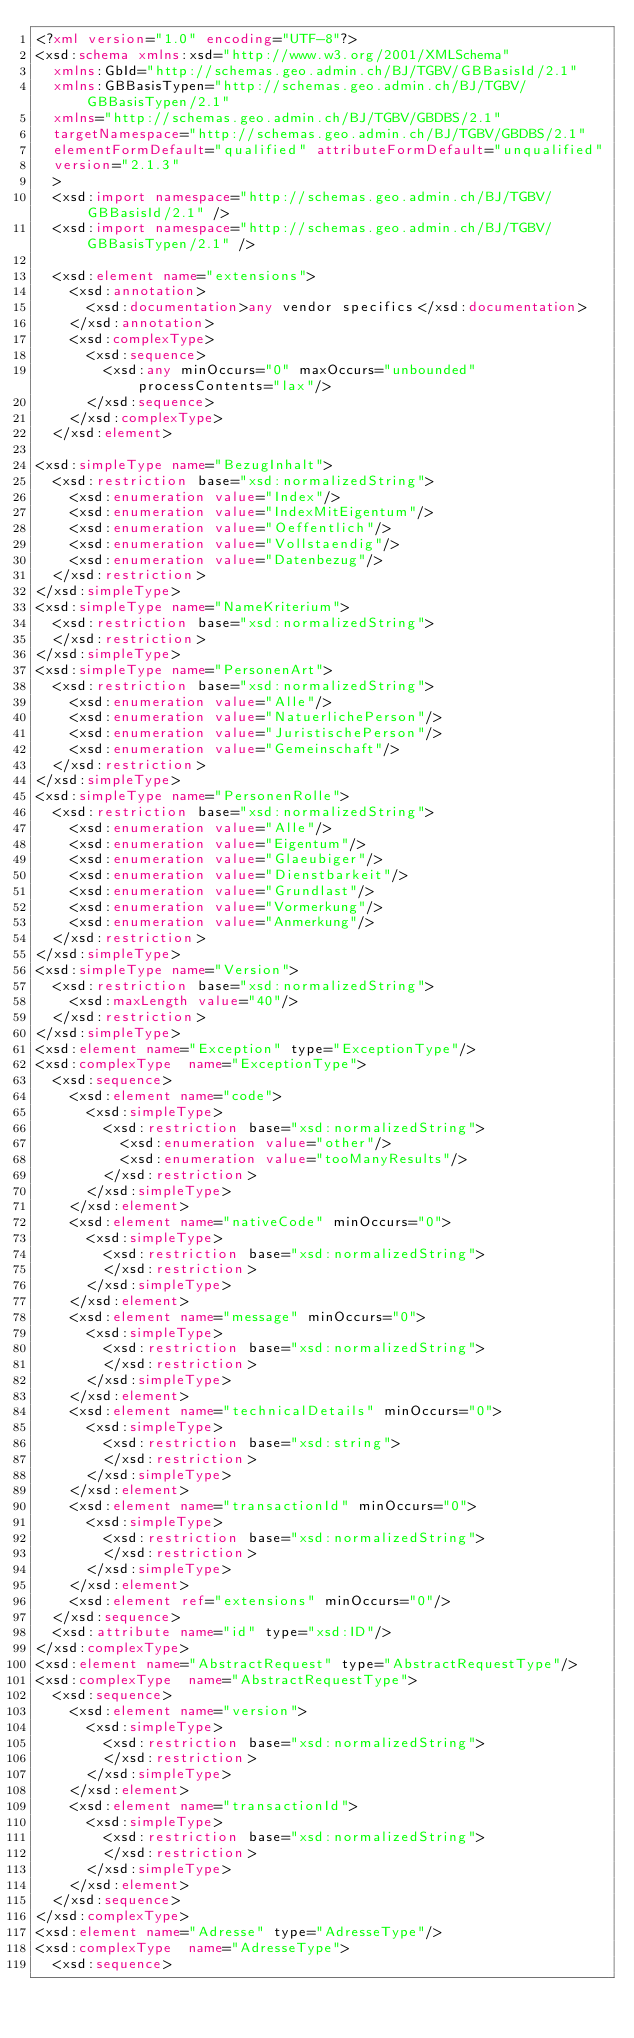<code> <loc_0><loc_0><loc_500><loc_500><_XML_><?xml version="1.0" encoding="UTF-8"?>
<xsd:schema xmlns:xsd="http://www.w3.org/2001/XMLSchema"
  xmlns:GbId="http://schemas.geo.admin.ch/BJ/TGBV/GBBasisId/2.1"
  xmlns:GBBasisTypen="http://schemas.geo.admin.ch/BJ/TGBV/GBBasisTypen/2.1"
  xmlns="http://schemas.geo.admin.ch/BJ/TGBV/GBDBS/2.1" 
  targetNamespace="http://schemas.geo.admin.ch/BJ/TGBV/GBDBS/2.1" 
  elementFormDefault="qualified" attributeFormDefault="unqualified"
  version="2.1.3"
  >
  <xsd:import namespace="http://schemas.geo.admin.ch/BJ/TGBV/GBBasisId/2.1" />
  <xsd:import namespace="http://schemas.geo.admin.ch/BJ/TGBV/GBBasisTypen/2.1" />

  <xsd:element name="extensions">
    <xsd:annotation>
      <xsd:documentation>any vendor specifics</xsd:documentation>
    </xsd:annotation>
    <xsd:complexType>
      <xsd:sequence>
        <xsd:any minOccurs="0" maxOccurs="unbounded" processContents="lax"/>
      </xsd:sequence>
    </xsd:complexType>
  </xsd:element>
  
<xsd:simpleType name="BezugInhalt">
  <xsd:restriction base="xsd:normalizedString">
    <xsd:enumeration value="Index"/>
    <xsd:enumeration value="IndexMitEigentum"/>
    <xsd:enumeration value="Oeffentlich"/>
    <xsd:enumeration value="Vollstaendig"/>
    <xsd:enumeration value="Datenbezug"/>
  </xsd:restriction>
</xsd:simpleType>
<xsd:simpleType name="NameKriterium">
  <xsd:restriction base="xsd:normalizedString">
  </xsd:restriction>
</xsd:simpleType>
<xsd:simpleType name="PersonenArt">
  <xsd:restriction base="xsd:normalizedString">
    <xsd:enumeration value="Alle"/>
    <xsd:enumeration value="NatuerlichePerson"/>
    <xsd:enumeration value="JuristischePerson"/>
    <xsd:enumeration value="Gemeinschaft"/>
  </xsd:restriction>
</xsd:simpleType>
<xsd:simpleType name="PersonenRolle">
  <xsd:restriction base="xsd:normalizedString">
    <xsd:enumeration value="Alle"/>
    <xsd:enumeration value="Eigentum"/>
    <xsd:enumeration value="Glaeubiger"/>
    <xsd:enumeration value="Dienstbarkeit"/>
    <xsd:enumeration value="Grundlast"/>
    <xsd:enumeration value="Vormerkung"/>
    <xsd:enumeration value="Anmerkung"/>
  </xsd:restriction>
</xsd:simpleType>
<xsd:simpleType name="Version">
  <xsd:restriction base="xsd:normalizedString">
    <xsd:maxLength value="40"/>
  </xsd:restriction>
</xsd:simpleType>
<xsd:element name="Exception" type="ExceptionType"/>
<xsd:complexType  name="ExceptionType">
  <xsd:sequence>
    <xsd:element name="code">
      <xsd:simpleType>
        <xsd:restriction base="xsd:normalizedString">
          <xsd:enumeration value="other"/>
          <xsd:enumeration value="tooManyResults"/>
        </xsd:restriction>
      </xsd:simpleType>
    </xsd:element>
    <xsd:element name="nativeCode" minOccurs="0">
      <xsd:simpleType>
        <xsd:restriction base="xsd:normalizedString">
        </xsd:restriction>
      </xsd:simpleType>
    </xsd:element>
    <xsd:element name="message" minOccurs="0">
      <xsd:simpleType>
        <xsd:restriction base="xsd:normalizedString">
        </xsd:restriction>
      </xsd:simpleType>
    </xsd:element>
    <xsd:element name="technicalDetails" minOccurs="0">
      <xsd:simpleType>
        <xsd:restriction base="xsd:string">
        </xsd:restriction>
      </xsd:simpleType>
    </xsd:element>
    <xsd:element name="transactionId" minOccurs="0">
      <xsd:simpleType>
        <xsd:restriction base="xsd:normalizedString">
        </xsd:restriction>
      </xsd:simpleType>
    </xsd:element>
    <xsd:element ref="extensions" minOccurs="0"/>
  </xsd:sequence>
  <xsd:attribute name="id" type="xsd:ID"/>
</xsd:complexType>
<xsd:element name="AbstractRequest" type="AbstractRequestType"/>
<xsd:complexType  name="AbstractRequestType">
  <xsd:sequence>
    <xsd:element name="version">
      <xsd:simpleType>
        <xsd:restriction base="xsd:normalizedString">
        </xsd:restriction>
      </xsd:simpleType>
    </xsd:element>
    <xsd:element name="transactionId">
      <xsd:simpleType>
        <xsd:restriction base="xsd:normalizedString">
        </xsd:restriction>
      </xsd:simpleType>
    </xsd:element>
  </xsd:sequence>
</xsd:complexType>
<xsd:element name="Adresse" type="AdresseType"/>
<xsd:complexType  name="AdresseType">
  <xsd:sequence></code> 